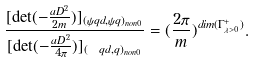Convert formula to latex. <formula><loc_0><loc_0><loc_500><loc_500>\frac { [ \det ( - \frac { { \sl a { D } } ^ { 2 } } { 2 m } ) ] _ { ( \psi q d , \psi q ) _ { n o n 0 } } } { [ \det ( - \frac { { \sl a { D } } ^ { 2 } } { 4 \pi } ) ] _ { ( \ q d , q ) _ { n o n 0 } } } = ( \frac { 2 \pi } { m } ) ^ { d i m ( \Gamma ^ { + } _ { \lambda > 0 } ) } .</formula> 